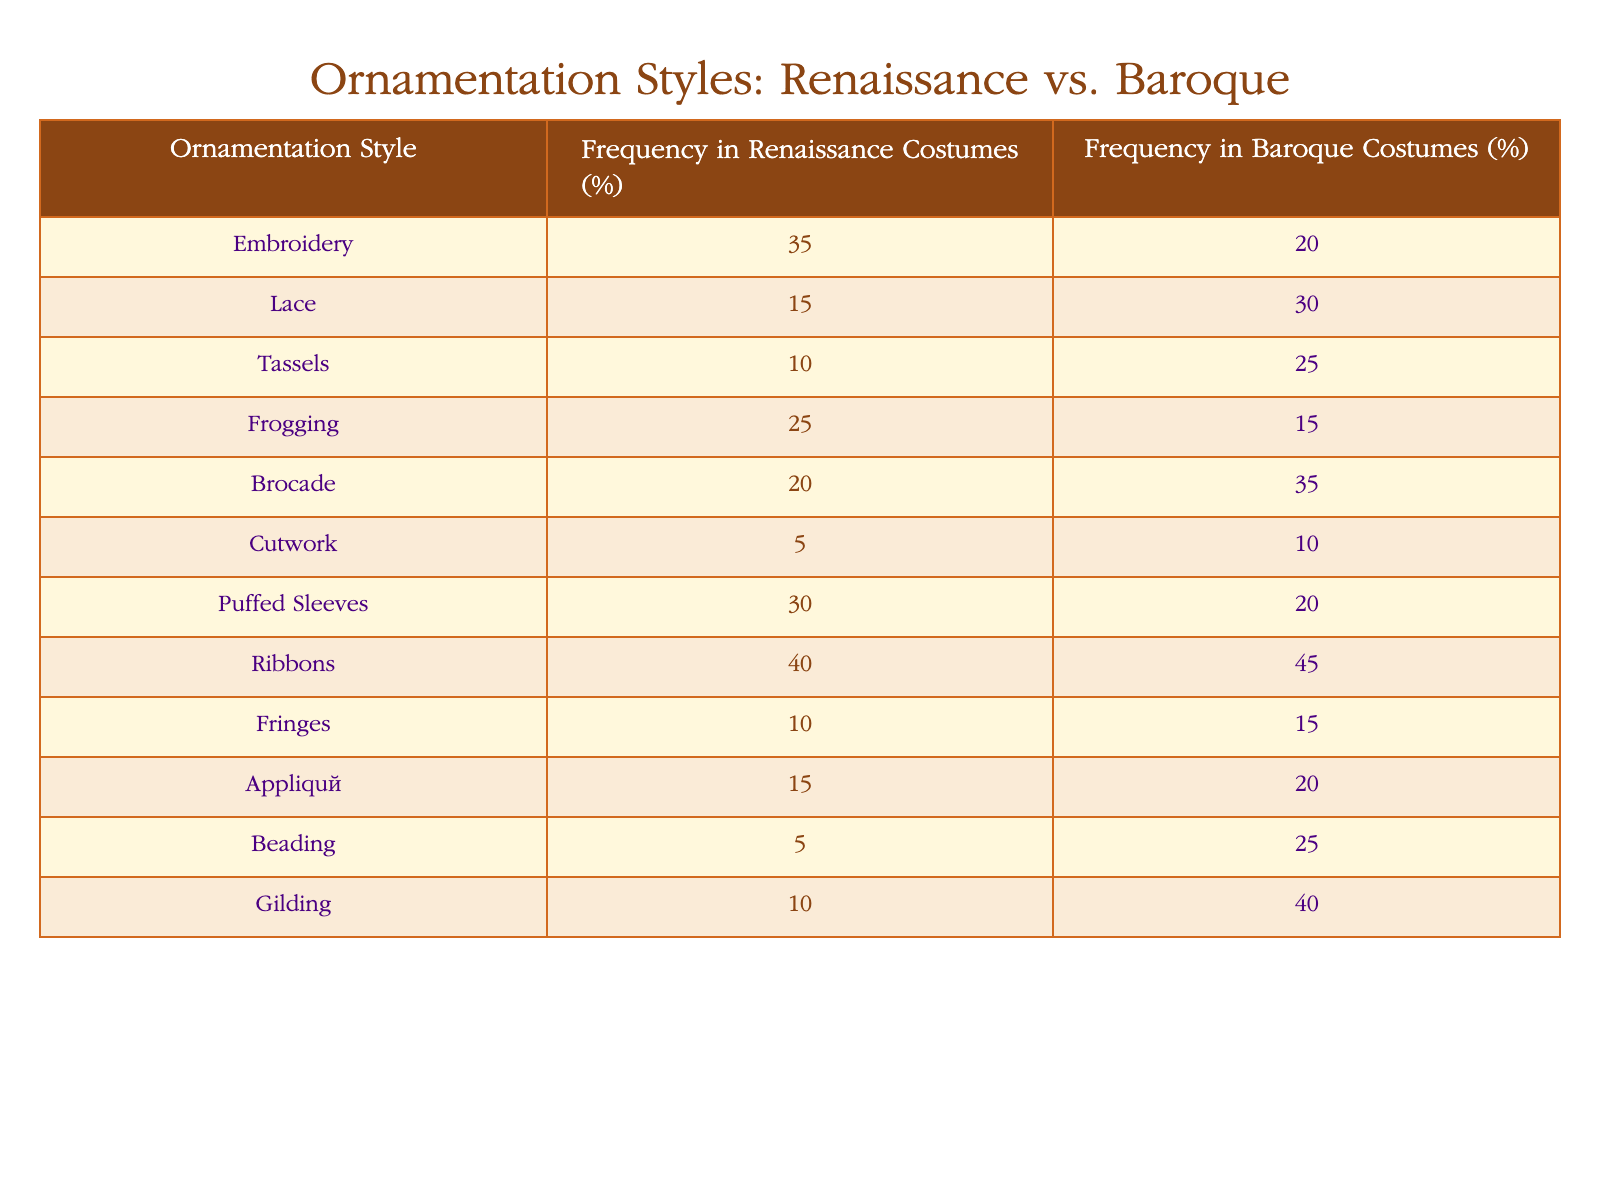What is the frequency of embroidery in Renaissance costumes? According to the table, the frequency of embroidery in Renaissance costumes is listed as 35%.
Answer: 35% Which ornamentation style has the highest frequency in Baroque costumes? In the Baroque section of the table, ribbons have the highest frequency at 45%.
Answer: Ribbons What is the difference in frequency for lace between Renaissance and Baroque costumes? Lace has a frequency of 15% in Renaissance costumes and 30% in Baroque costumes. The difference is calculated as 30% - 15% = 15%.
Answer: 15% Are puffed sleeves more prevalent in Renaissance or Baroque costumes? The table shows puffed sleeves at 30% in Renaissance costumes and 20% in Baroque costumes, indicating puffed sleeves are more prevalent in Renaissance costumes.
Answer: Yes What is the average frequency of ornamentation styles in Renaissance costumes? To find the average, sum the frequencies for Renaissance costumes: 35 + 15 + 10 + 25 + 20 + 5 + 30 + 40 + 10 + 15 + 5 + 10 =  275. Dividing by the number of styles (12) gives an average of 275/12 = approximately 22.92%.
Answer: 22.92% Which ornamentation style has the lowest frequency in Baroque costumes? From the data, cutwork has the lowest frequency at 10% in Baroque costumes.
Answer: Cutwork What is the total frequency of all ornamentation styles in Renaissance costumes? Adding all frequencies in the Renaissance costumes gives: 35 + 15 + 10 + 25 + 20 + 5 + 30 + 40 + 10 + 15 + 5 + 10 = 275%. Since this should represent individual costume components, the total percentage doesn't give meaningful direct reference but indicates many styles were utilized.
Answer: 275% Is there any ornamentation style with the same frequency in both Renaissance and Baroque costumes? By reviewing the table, no ornamentation styles have identical percentages in both periods.
Answer: No What is the difference between the total frequency of gilding in both costume styles? Gilding has a frequency of 10% in Renaissance costumes and 40% in Baroque costumes. The difference is 40% - 10% = 30%.
Answer: 30% 